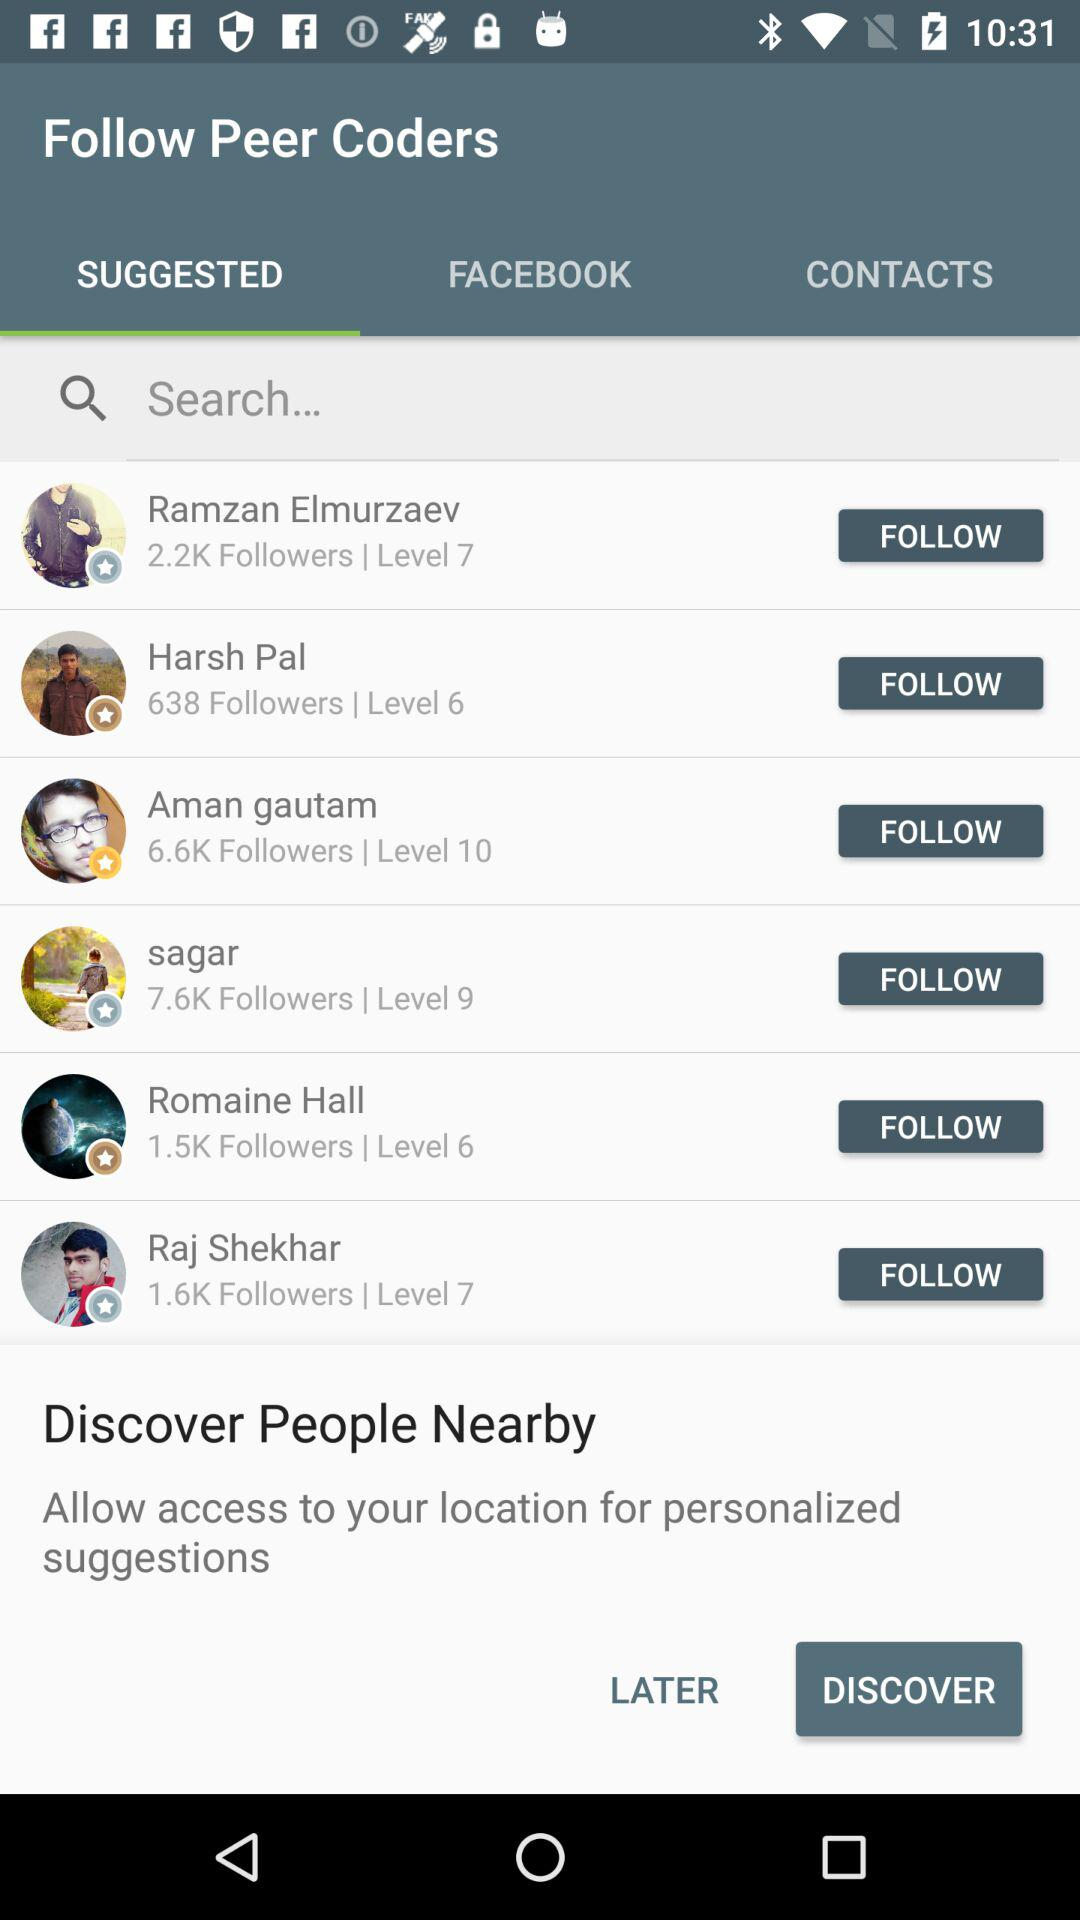Which tab has been selected? The selected tab is "SUGGESTED". 